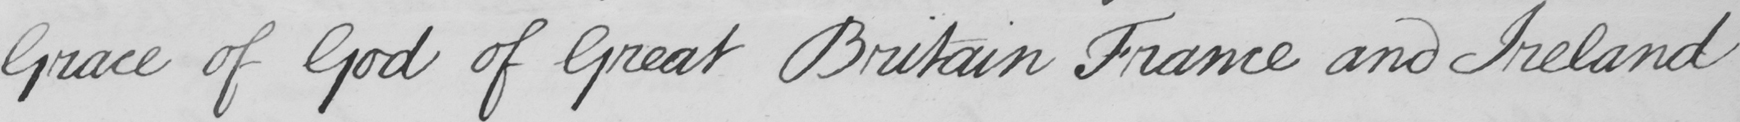Can you tell me what this handwritten text says? Grace of God of Great Britain France and Ireland 